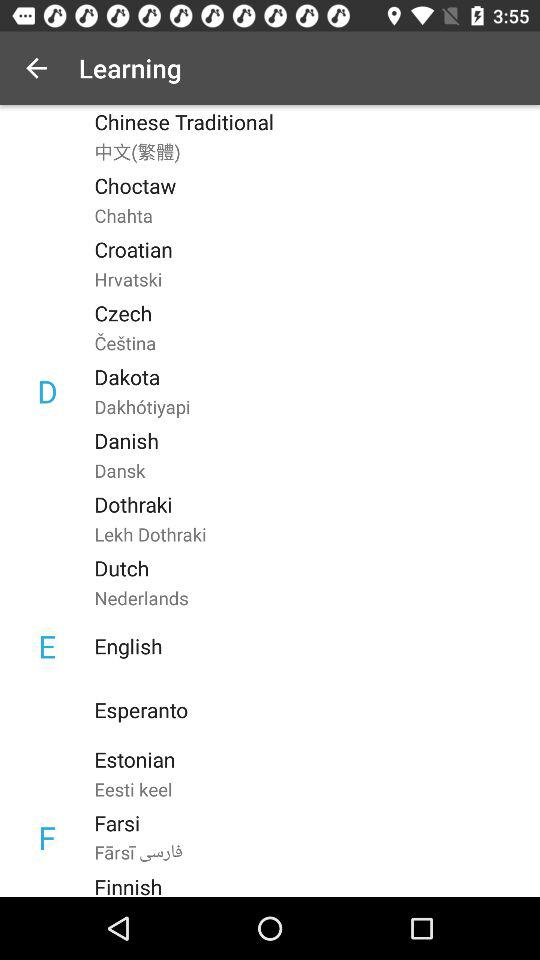What are the requirements for logging in?
When the provided information is insufficient, respond with <no answer>. <no answer> 